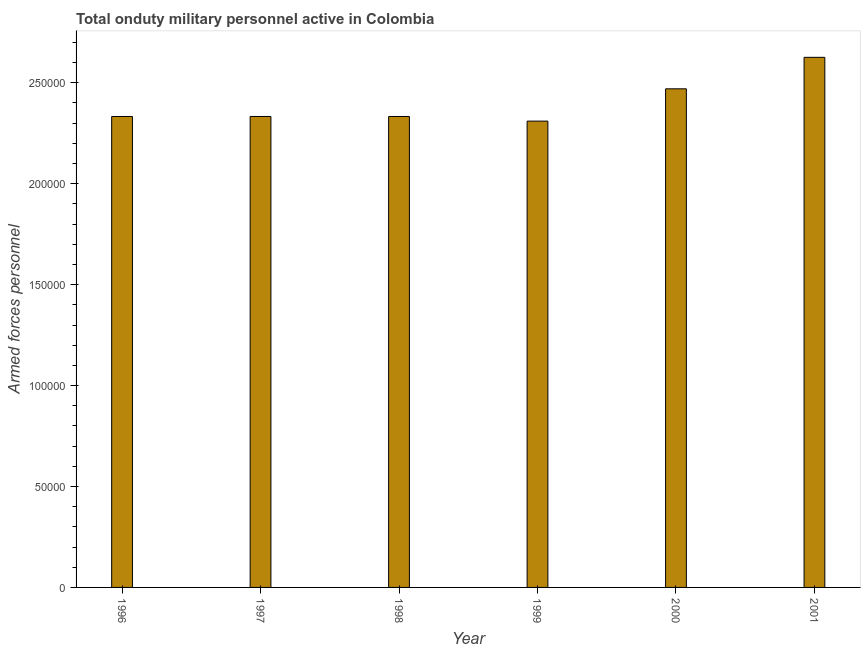Does the graph contain grids?
Your response must be concise. No. What is the title of the graph?
Provide a succinct answer. Total onduty military personnel active in Colombia. What is the label or title of the Y-axis?
Your answer should be very brief. Armed forces personnel. What is the number of armed forces personnel in 1997?
Give a very brief answer. 2.33e+05. Across all years, what is the maximum number of armed forces personnel?
Ensure brevity in your answer.  2.63e+05. Across all years, what is the minimum number of armed forces personnel?
Provide a succinct answer. 2.31e+05. What is the sum of the number of armed forces personnel?
Keep it short and to the point. 1.44e+06. What is the average number of armed forces personnel per year?
Keep it short and to the point. 2.40e+05. What is the median number of armed forces personnel?
Ensure brevity in your answer.  2.33e+05. In how many years, is the number of armed forces personnel greater than 230000 ?
Ensure brevity in your answer.  6. What is the ratio of the number of armed forces personnel in 1998 to that in 2000?
Offer a very short reply. 0.94. Is the number of armed forces personnel in 1998 less than that in 2001?
Keep it short and to the point. Yes. What is the difference between the highest and the second highest number of armed forces personnel?
Offer a terse response. 1.56e+04. What is the difference between the highest and the lowest number of armed forces personnel?
Give a very brief answer. 3.16e+04. In how many years, is the number of armed forces personnel greater than the average number of armed forces personnel taken over all years?
Provide a succinct answer. 2. How many bars are there?
Ensure brevity in your answer.  6. Are all the bars in the graph horizontal?
Provide a short and direct response. No. What is the Armed forces personnel of 1996?
Give a very brief answer. 2.33e+05. What is the Armed forces personnel of 1997?
Your response must be concise. 2.33e+05. What is the Armed forces personnel of 1998?
Your answer should be very brief. 2.33e+05. What is the Armed forces personnel of 1999?
Your response must be concise. 2.31e+05. What is the Armed forces personnel of 2000?
Provide a short and direct response. 2.47e+05. What is the Armed forces personnel in 2001?
Make the answer very short. 2.63e+05. What is the difference between the Armed forces personnel in 1996 and 1998?
Keep it short and to the point. 0. What is the difference between the Armed forces personnel in 1996 and 1999?
Offer a very short reply. 2300. What is the difference between the Armed forces personnel in 1996 and 2000?
Provide a short and direct response. -1.37e+04. What is the difference between the Armed forces personnel in 1996 and 2001?
Provide a short and direct response. -2.93e+04. What is the difference between the Armed forces personnel in 1997 and 1999?
Your answer should be very brief. 2300. What is the difference between the Armed forces personnel in 1997 and 2000?
Keep it short and to the point. -1.37e+04. What is the difference between the Armed forces personnel in 1997 and 2001?
Keep it short and to the point. -2.93e+04. What is the difference between the Armed forces personnel in 1998 and 1999?
Provide a succinct answer. 2300. What is the difference between the Armed forces personnel in 1998 and 2000?
Offer a terse response. -1.37e+04. What is the difference between the Armed forces personnel in 1998 and 2001?
Give a very brief answer. -2.93e+04. What is the difference between the Armed forces personnel in 1999 and 2000?
Provide a short and direct response. -1.60e+04. What is the difference between the Armed forces personnel in 1999 and 2001?
Your answer should be very brief. -3.16e+04. What is the difference between the Armed forces personnel in 2000 and 2001?
Your answer should be very brief. -1.56e+04. What is the ratio of the Armed forces personnel in 1996 to that in 1999?
Offer a very short reply. 1.01. What is the ratio of the Armed forces personnel in 1996 to that in 2000?
Offer a very short reply. 0.94. What is the ratio of the Armed forces personnel in 1996 to that in 2001?
Give a very brief answer. 0.89. What is the ratio of the Armed forces personnel in 1997 to that in 2000?
Make the answer very short. 0.94. What is the ratio of the Armed forces personnel in 1997 to that in 2001?
Offer a very short reply. 0.89. What is the ratio of the Armed forces personnel in 1998 to that in 2000?
Provide a succinct answer. 0.94. What is the ratio of the Armed forces personnel in 1998 to that in 2001?
Make the answer very short. 0.89. What is the ratio of the Armed forces personnel in 1999 to that in 2000?
Ensure brevity in your answer.  0.94. What is the ratio of the Armed forces personnel in 2000 to that in 2001?
Your answer should be compact. 0.94. 